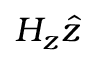Convert formula to latex. <formula><loc_0><loc_0><loc_500><loc_500>H _ { z } \hat { z }</formula> 